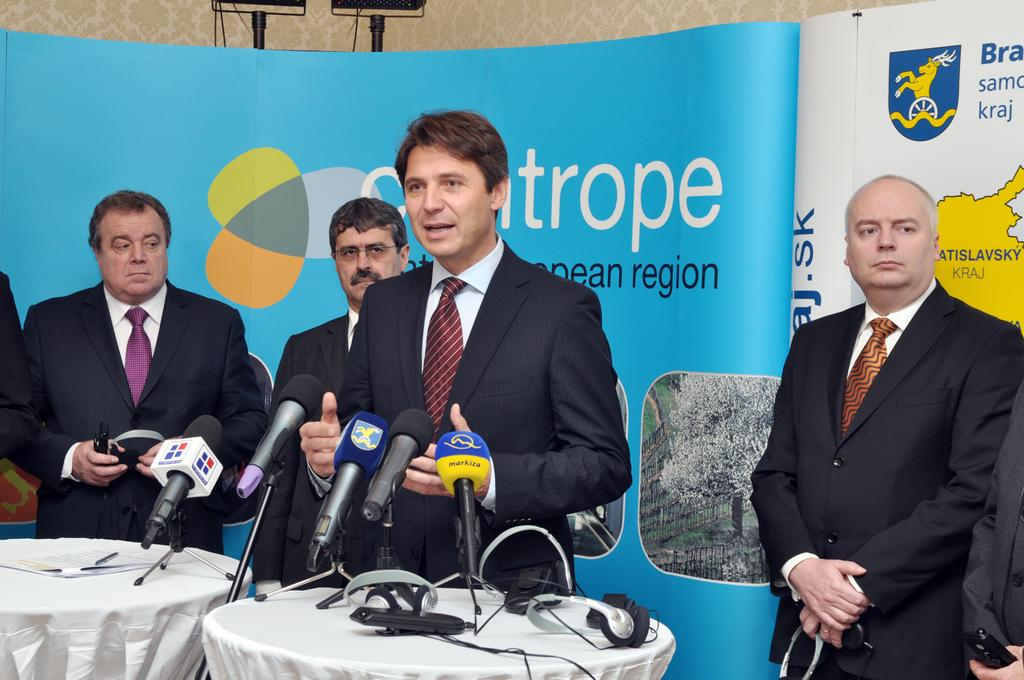What can be seen in the foreground of the picture? In the foreground of the picture, there are people, tables, microphones, cables, papers, and pens. What objects are present on the tables in the foreground? The tables in the foreground have microphones, cables, papers, and pens on them. What is visible in the background of the picture? In the background of the picture, there are stands, a banner, and a wall. What type of jeans are the people wearing in the picture? There is no information about the clothing of the people in the picture, so we cannot determine if they are wearing jeans or any other type of clothing. What is the title of the event being held in the picture? There is no title mentioned in the picture, so we cannot determine the name of the event. 